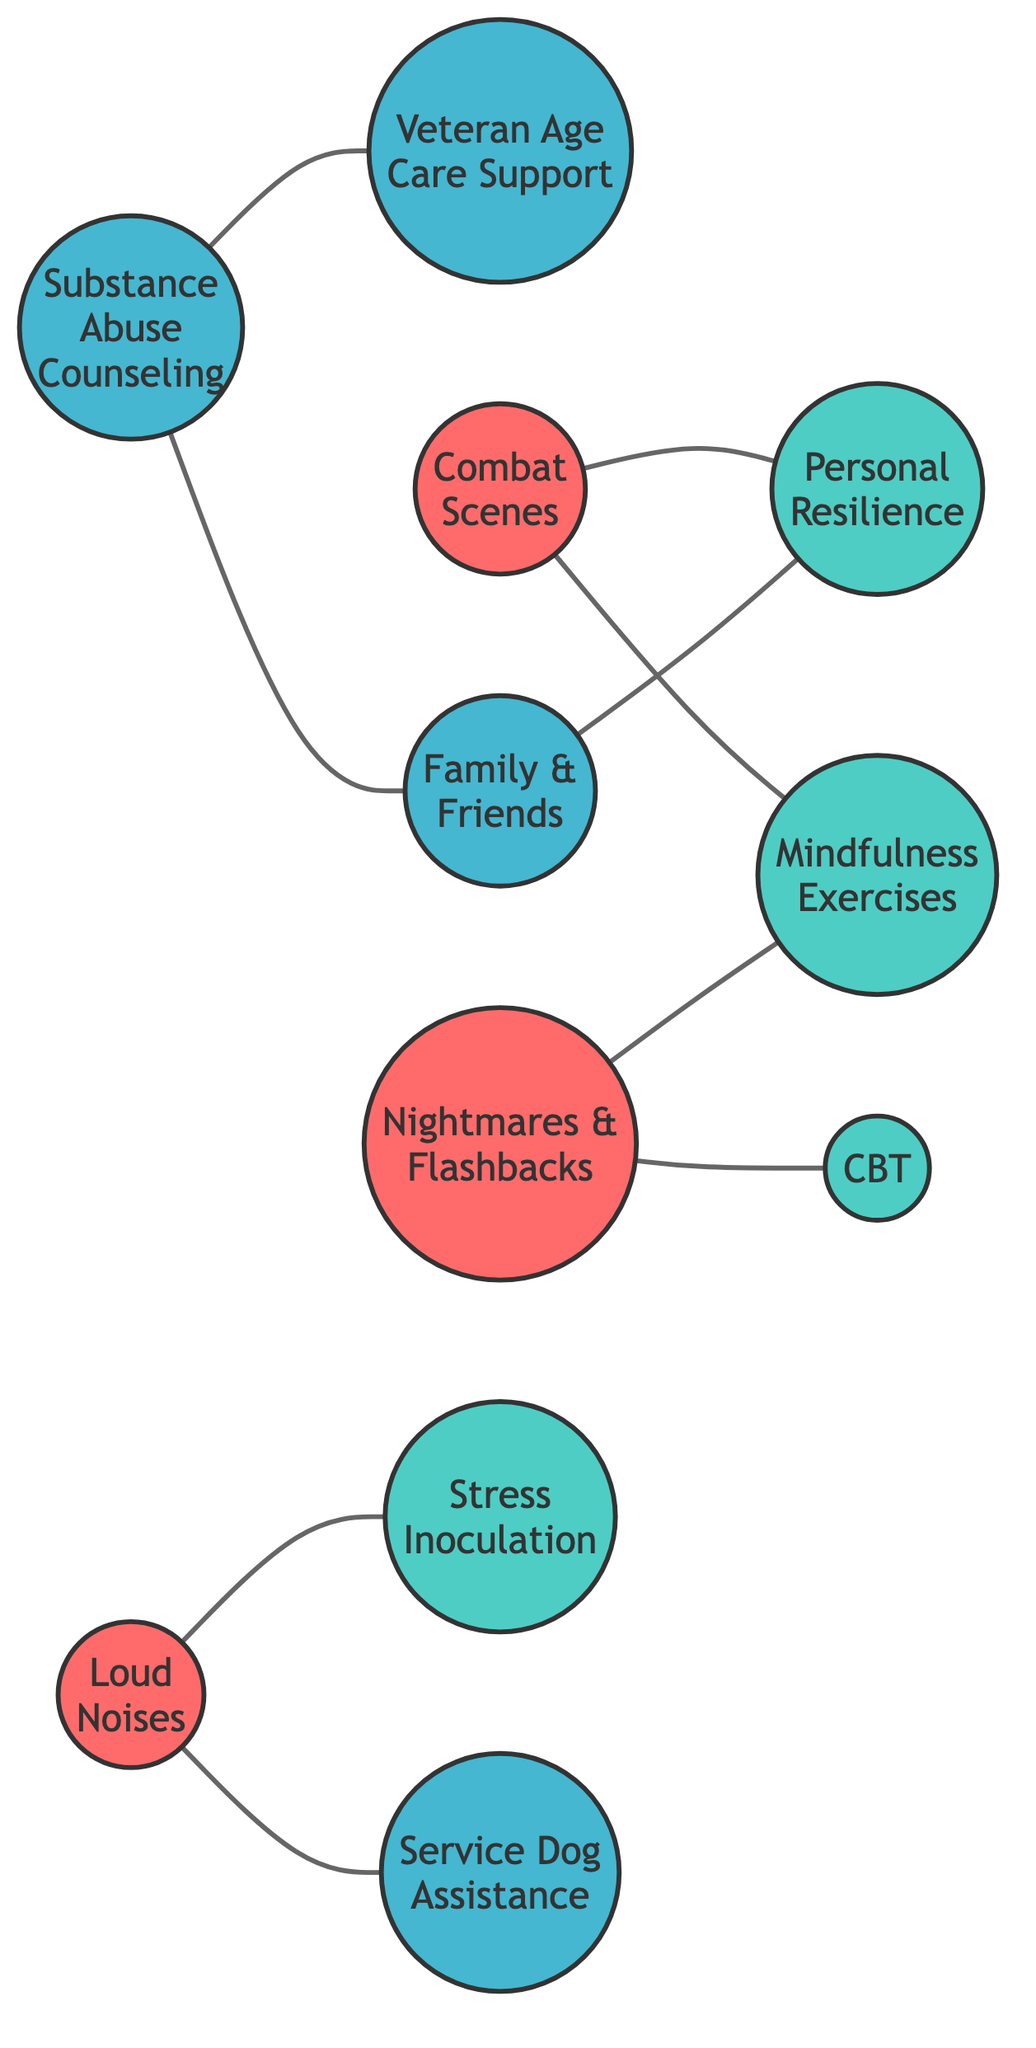What is the total number of nodes in the diagram? The nodes are represented as individual entities in the diagram. There are 11 nodes listed in the data provided.
Answer: 11 What trigger is connected to Personal Resilience Techniques? According to the edges, Exposure to Combat Scenes is linked to Personal Resilience Techniques within the diagram.
Answer: Exposure to Combat Scenes How many coping strategies are mentioned in the diagram? The coping strategies are represented by the nodes labeled strategies. There are five strategies listed: Personal Resilience Techniques, Mindfulness Exercises, Cognitive Behavioral Therapy, Stress Inoculation Training, and Family and Friends Support. Thus, there are five strategies.
Answer: 5 Which support system is connected to Substance Abuse Counseling? The edges indicate that Substance Abuse Counseling is linked to two support systems: Family and Friends Support and Veteran Age Care Support Group.
Answer: Family and Friends Support, Veteran Age Care Support Group What is the relationship between Loud Noises and Service Dog Assistance? The diagram shows an undirected edge connecting Loud Noises to Service Dog Assistance, indicating that they are directly related.
Answer: Directly related What are the triggers associated with Mindfulness Exercises? By analyzing the edges connected to Mindfulness Exercises, we see it is linked to two triggers: Exposure to Combat Scenes and Nightmares and Flashbacks.
Answer: Exposure to Combat Scenes, Nightmares and Flashbacks Which coping strategy connects both Loud Noises and Nightmares and Flashbacks? The edge between Loud Noises and Stress Inoculation Training indicates that Stress Inoculation Training is the strategy connecting both of these triggers, albeit they are connected to different nodes.
Answer: Stress Inoculation Training Are there any support systems directly connected to Personal Resilience Techniques? According to the edge connections, Family and Friends Support is the only support system that is directly connected to Personal Resilience Techniques in the diagram.
Answer: Family and Friends Support How many edges are in the diagram? The edges represent the connections between the nodes. By counting each connection listed, there are 8 edges in the diagram, depicting the relationships among the different entities.
Answer: 8 